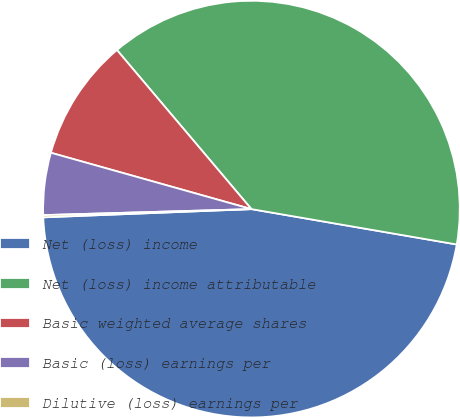Convert chart. <chart><loc_0><loc_0><loc_500><loc_500><pie_chart><fcel>Net (loss) income<fcel>Net (loss) income attributable<fcel>Basic weighted average shares<fcel>Basic (loss) earnings per<fcel>Dilutive (loss) earnings per<nl><fcel>46.66%<fcel>38.89%<fcel>9.47%<fcel>4.82%<fcel>0.17%<nl></chart> 